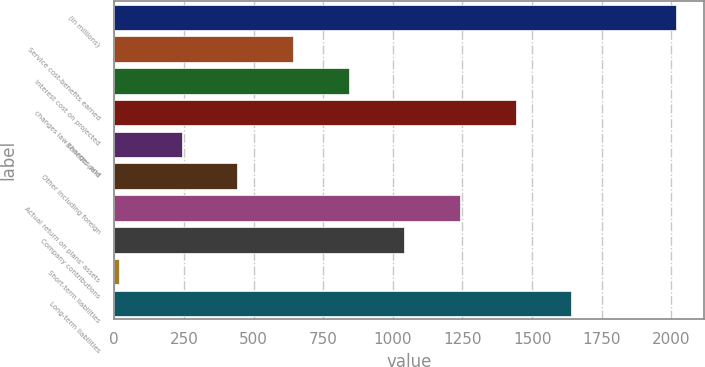Convert chart to OTSL. <chart><loc_0><loc_0><loc_500><loc_500><bar_chart><fcel>(in millions)<fcel>Service cost-benefits earned<fcel>Interest cost on projected<fcel>changes law changes and<fcel>Benefits paid<fcel>Other including foreign<fcel>Actual return on plans' assets<fcel>Company contributions<fcel>Short-term liabilities<fcel>Long-term liabilities<nl><fcel>2016<fcel>641.6<fcel>841.4<fcel>1440.8<fcel>242<fcel>441.8<fcel>1241<fcel>1041.2<fcel>18<fcel>1640.6<nl></chart> 